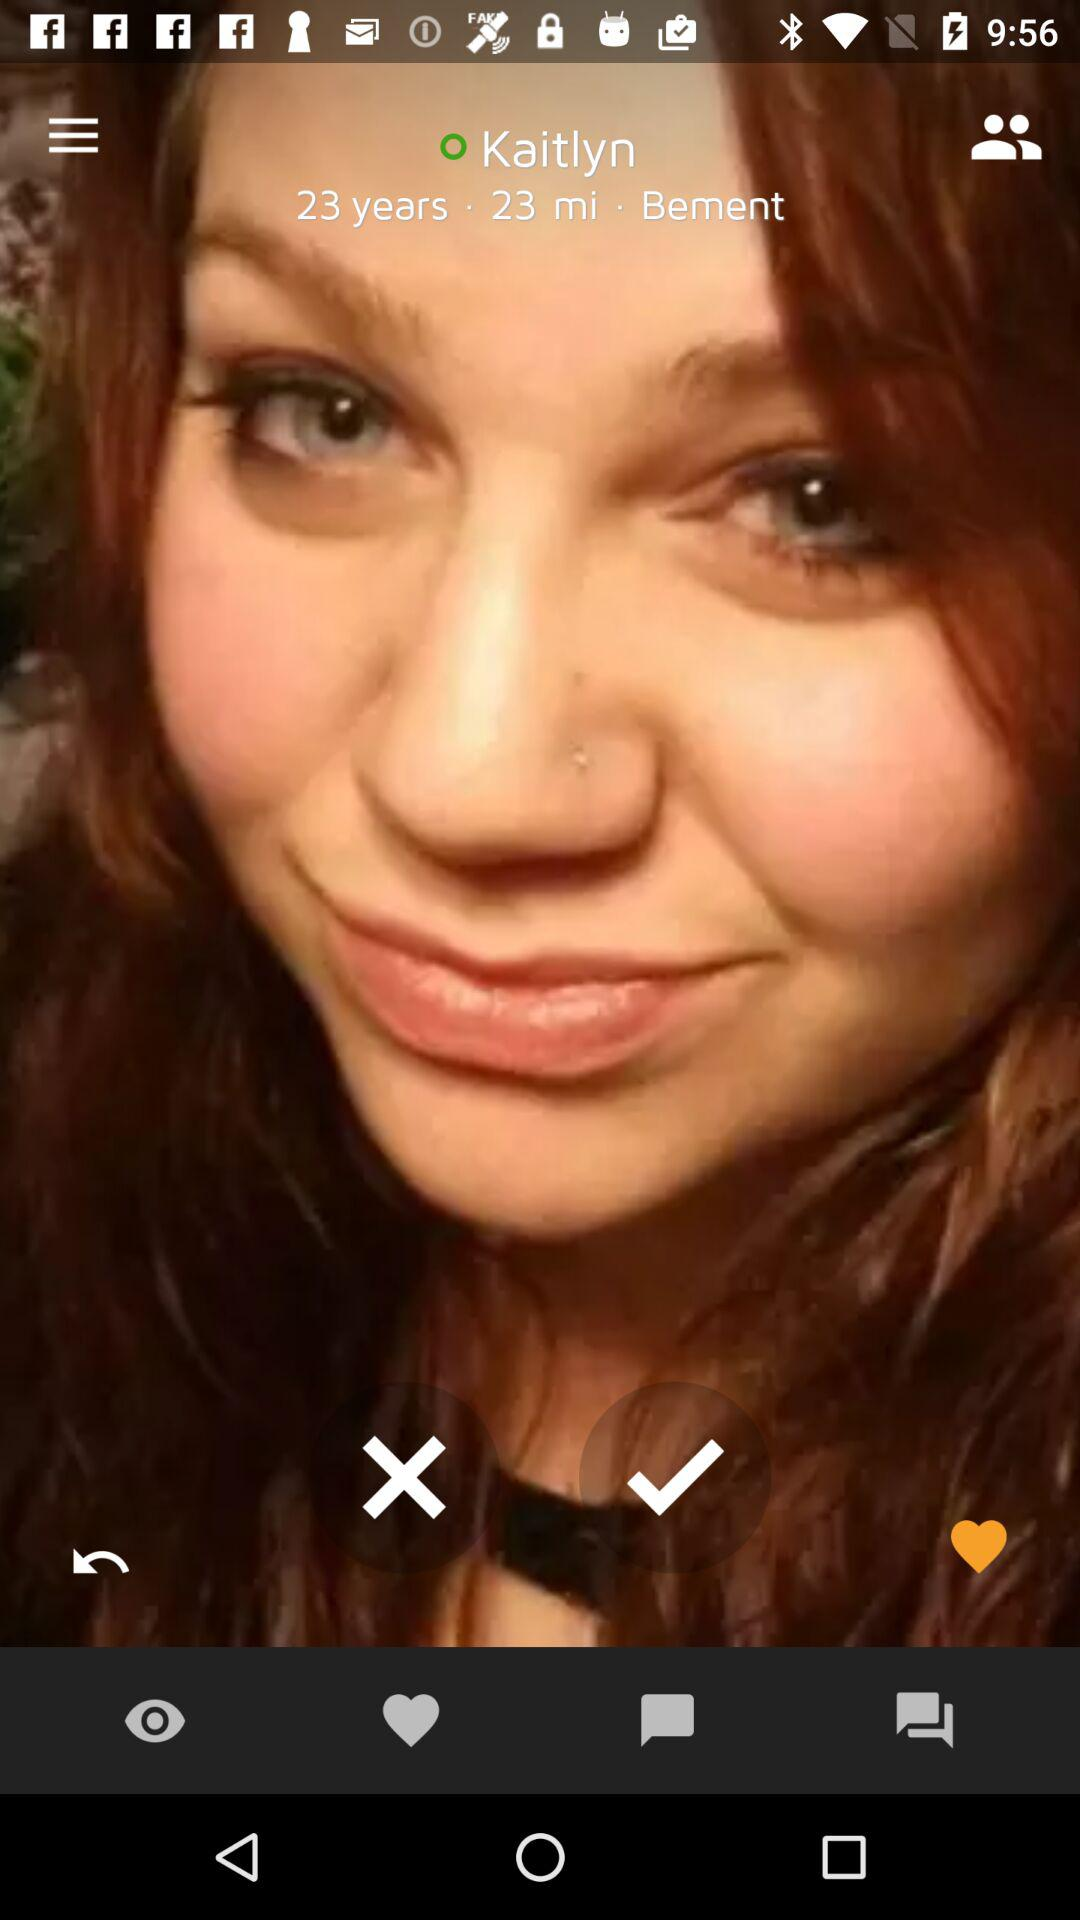What is the shown distance? The shown distance is 23 miles. 